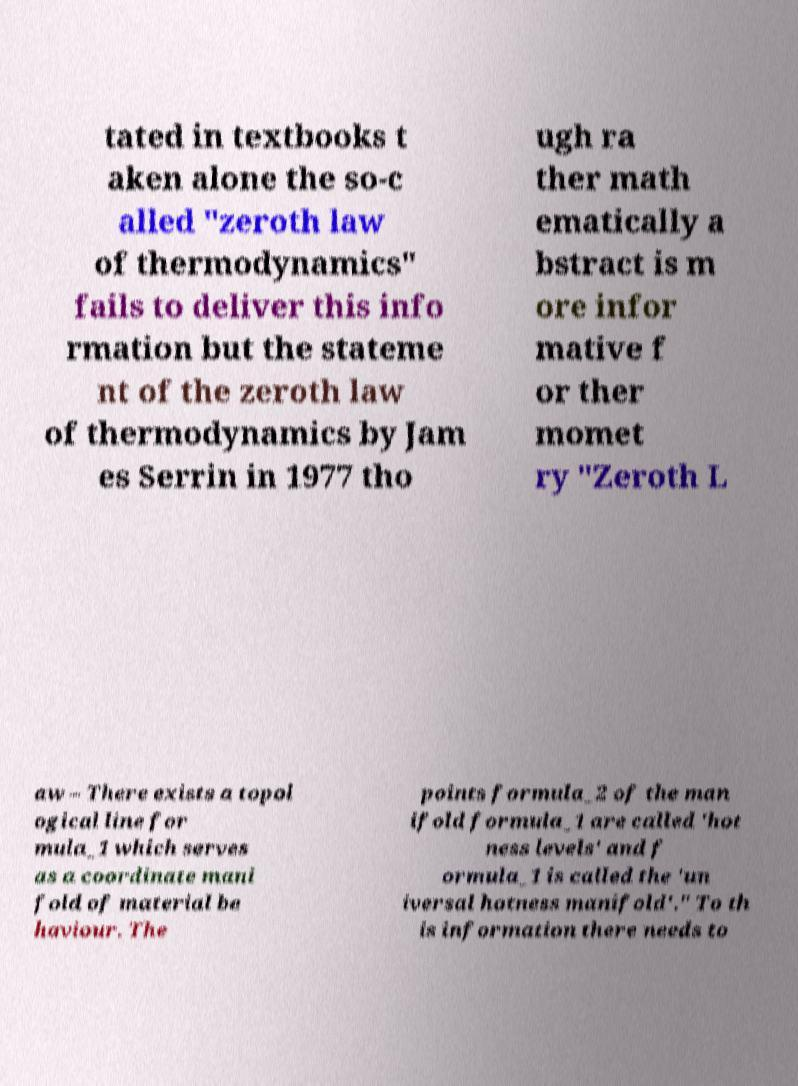For documentation purposes, I need the text within this image transcribed. Could you provide that? tated in textbooks t aken alone the so-c alled "zeroth law of thermodynamics" fails to deliver this info rmation but the stateme nt of the zeroth law of thermodynamics by Jam es Serrin in 1977 tho ugh ra ther math ematically a bstract is m ore infor mative f or ther momet ry "Zeroth L aw – There exists a topol ogical line for mula_1 which serves as a coordinate mani fold of material be haviour. The points formula_2 of the man ifold formula_1 are called 'hot ness levels' and f ormula_1 is called the 'un iversal hotness manifold'." To th is information there needs to 